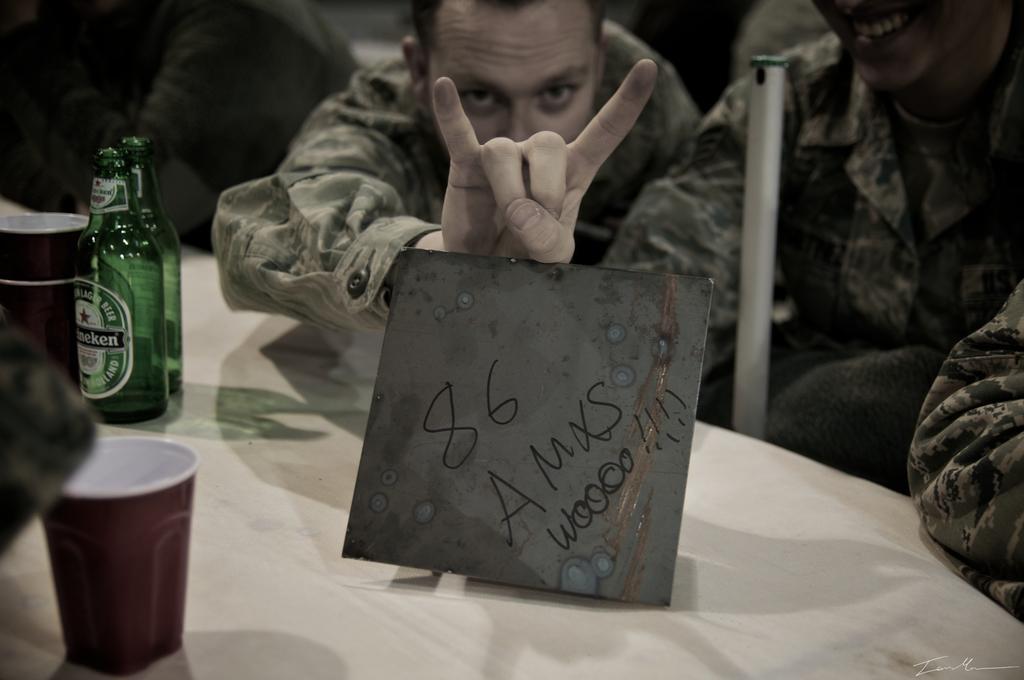In one or two sentences, can you explain what this image depicts? This picture shows two men seated on chairs and a man holding a placard and we see a two bottles and two cups on the table. 